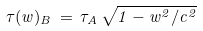Convert formula to latex. <formula><loc_0><loc_0><loc_500><loc_500>\tau ( w ) _ { B } \, = \, \tau _ { A } \, \sqrt { 1 - w ^ { 2 } / c ^ { 2 } }</formula> 